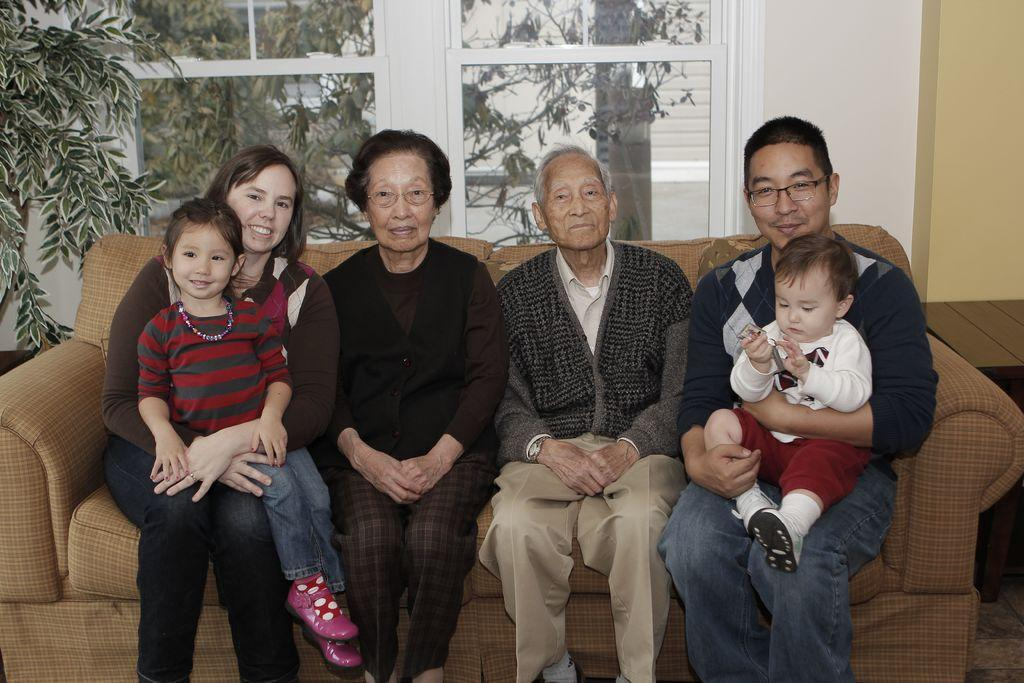How many people are sitting on the sofa in the image? There are 4 persons sitting on the sofa. What are the people on the sofa doing? Each person is holding a kid in their lap. What can be seen behind the sofa through the windows? There are glass windows behind the sofa, and trees are visible outside the windows. What type of circle is being traded in the image? There is no mention of a circle or trade in the image; it features 4 persons sitting on a sofa, each holding a kid in their lap, with glass windows and trees visible outside. 